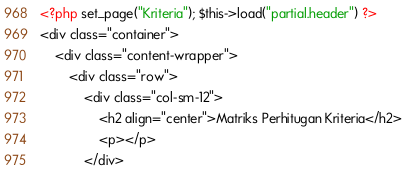Convert code to text. <code><loc_0><loc_0><loc_500><loc_500><_PHP_><?php set_page("Kriteria"); $this->load("partial.header") ?>
<div class="container">
	<div class="content-wrapper">
		<div class="row">
			<div class="col-sm-12">
				<h2 align="center">Matriks Perhitugan Kriteria</h2>
				<p></p>
			</div></code> 